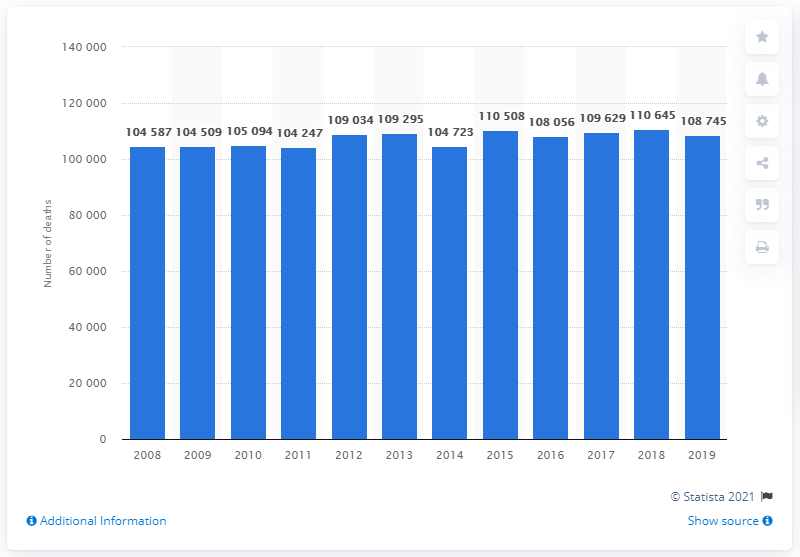Highlight a few significant elements in this photo. In 2018, the highest number of deaths in Belgium was 110,645. In 2019, there were 10,874 deaths in Belgium. 